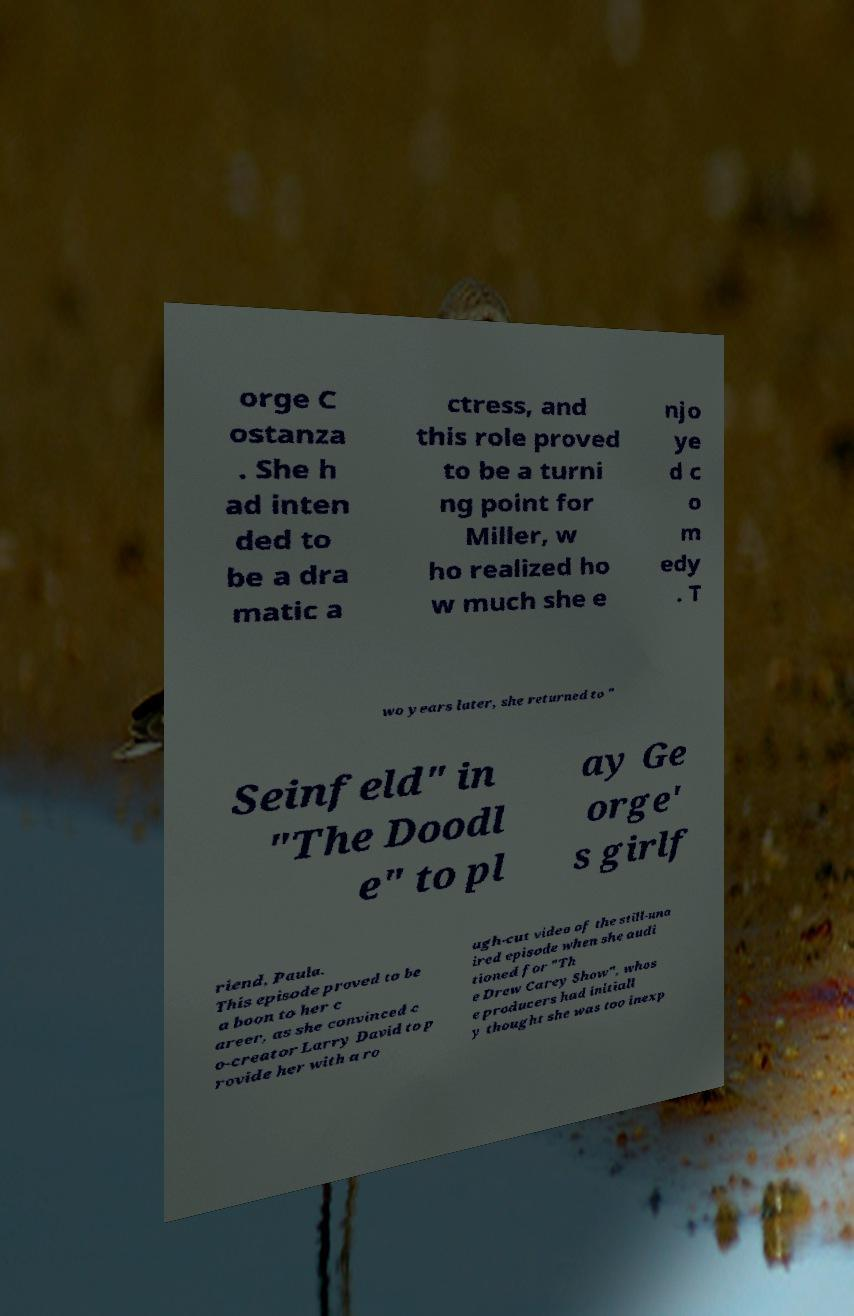Please read and relay the text visible in this image. What does it say? orge C ostanza . She h ad inten ded to be a dra matic a ctress, and this role proved to be a turni ng point for Miller, w ho realized ho w much she e njo ye d c o m edy . T wo years later, she returned to " Seinfeld" in "The Doodl e" to pl ay Ge orge' s girlf riend, Paula. This episode proved to be a boon to her c areer, as she convinced c o-creator Larry David to p rovide her with a ro ugh-cut video of the still-una ired episode when she audi tioned for "Th e Drew Carey Show", whos e producers had initiall y thought she was too inexp 